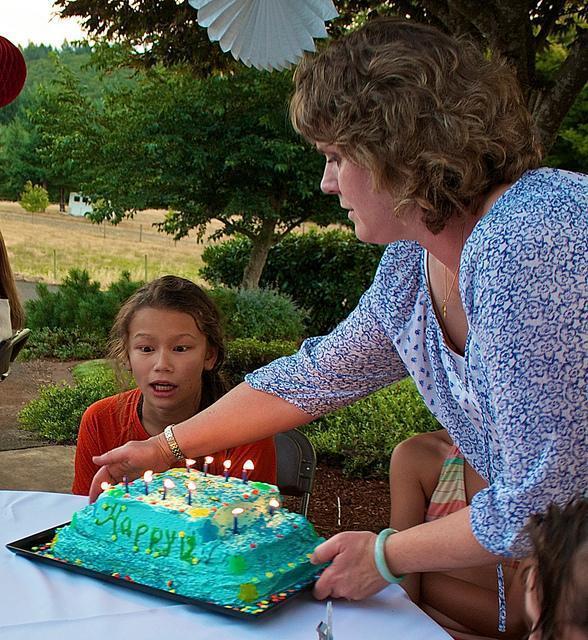Is the statement "The truck is on the cake." accurate regarding the image?
Answer yes or no. No. Is the caption "The dining table is far away from the truck." a true representation of the image?
Answer yes or no. Yes. Is this affirmation: "The truck is part of the cake." correct?
Answer yes or no. No. 